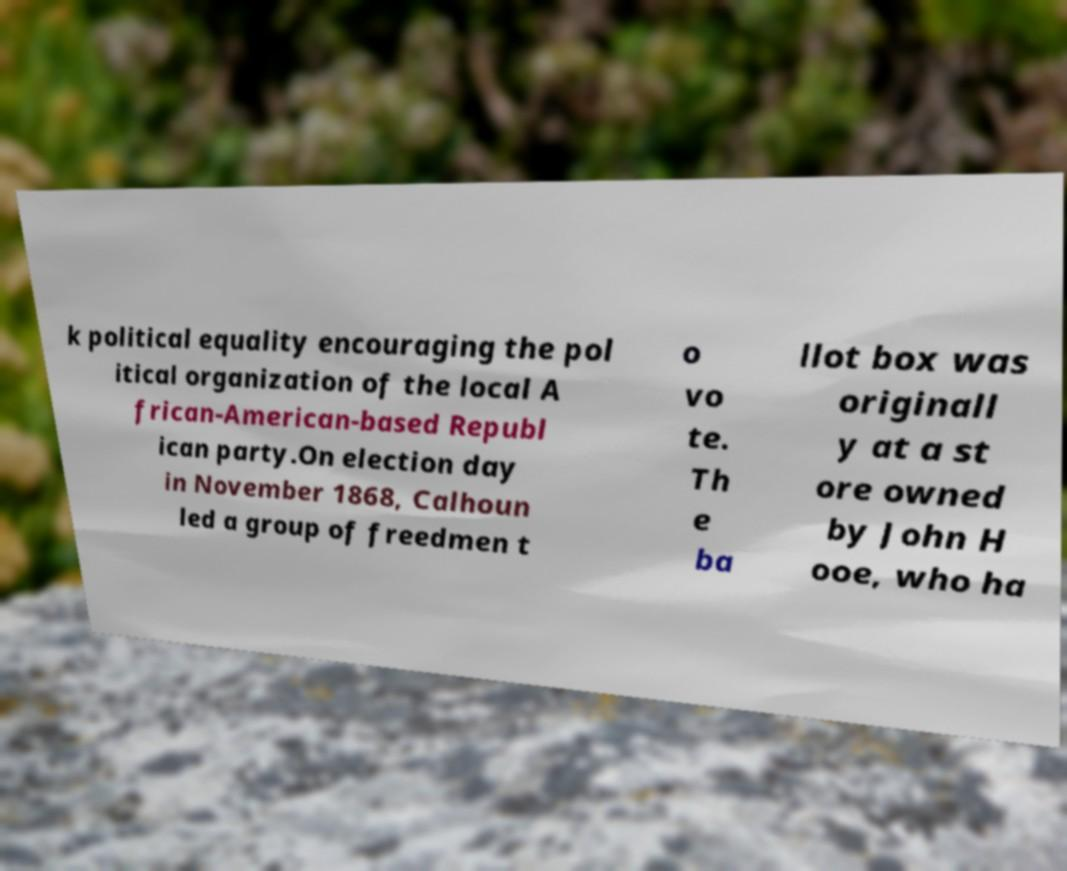For documentation purposes, I need the text within this image transcribed. Could you provide that? k political equality encouraging the pol itical organization of the local A frican-American-based Republ ican party.On election day in November 1868, Calhoun led a group of freedmen t o vo te. Th e ba llot box was originall y at a st ore owned by John H ooe, who ha 